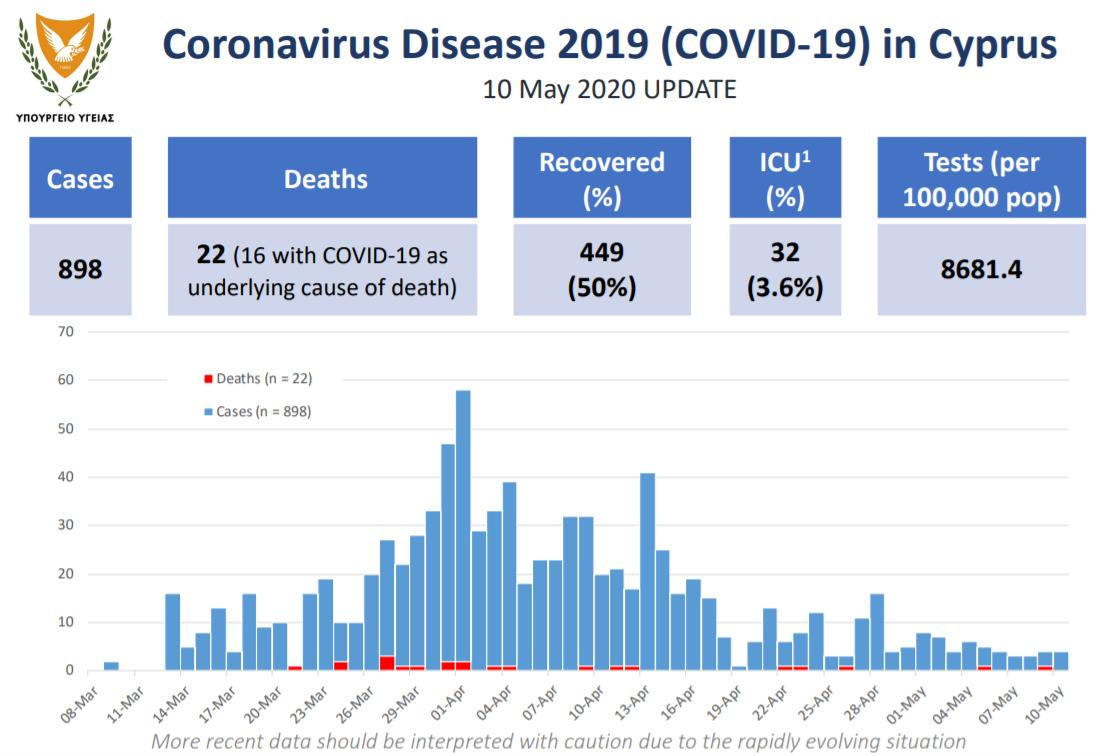Give some essential details in this illustration. On March 21, 2020, there were only deaths reported and not any confirmed cases of the pandemic. The lowest number of cases were reported on April 19th, 2020. The first case of COVID-19 death was reported on May 5, 2020. On April 13, 2020, the third highest number of cases were reported. On March 25, 2020, a total of 10 cases of the disease were reported. 